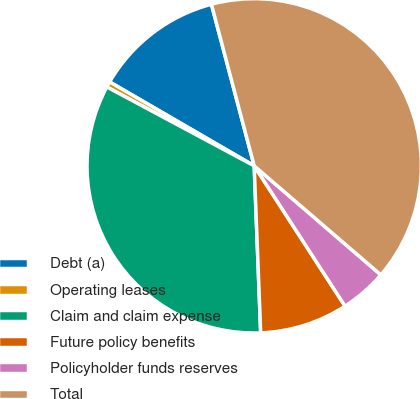Convert chart to OTSL. <chart><loc_0><loc_0><loc_500><loc_500><pie_chart><fcel>Debt (a)<fcel>Operating leases<fcel>Claim and claim expense<fcel>Future policy benefits<fcel>Policyholder funds reserves<fcel>Total<nl><fcel>12.51%<fcel>0.55%<fcel>33.44%<fcel>8.53%<fcel>4.54%<fcel>40.43%<nl></chart> 